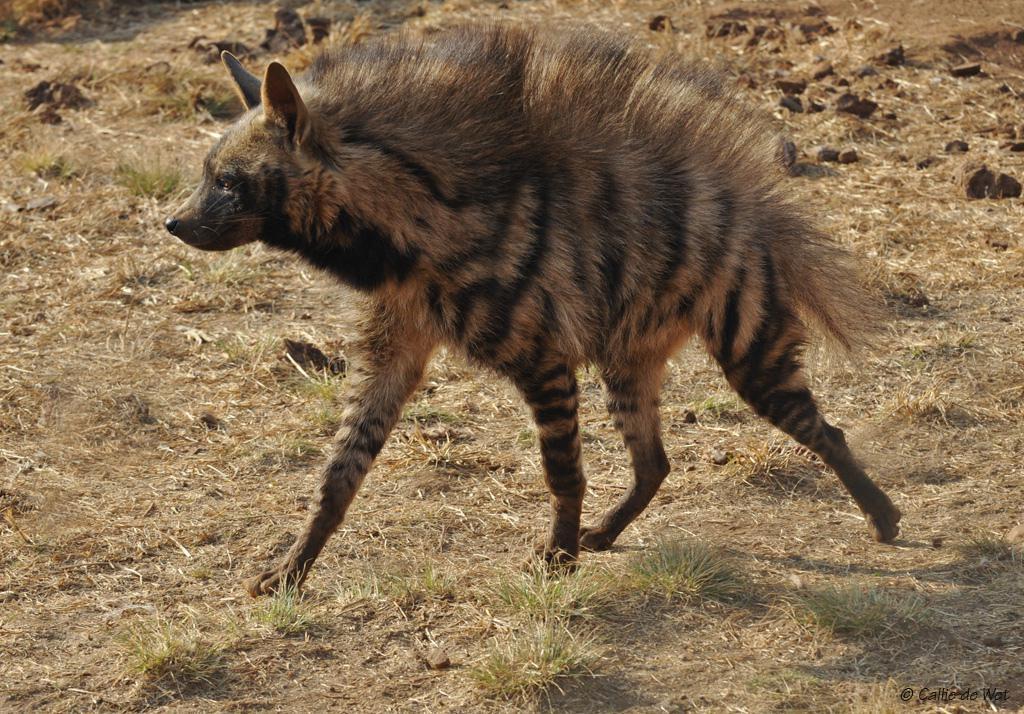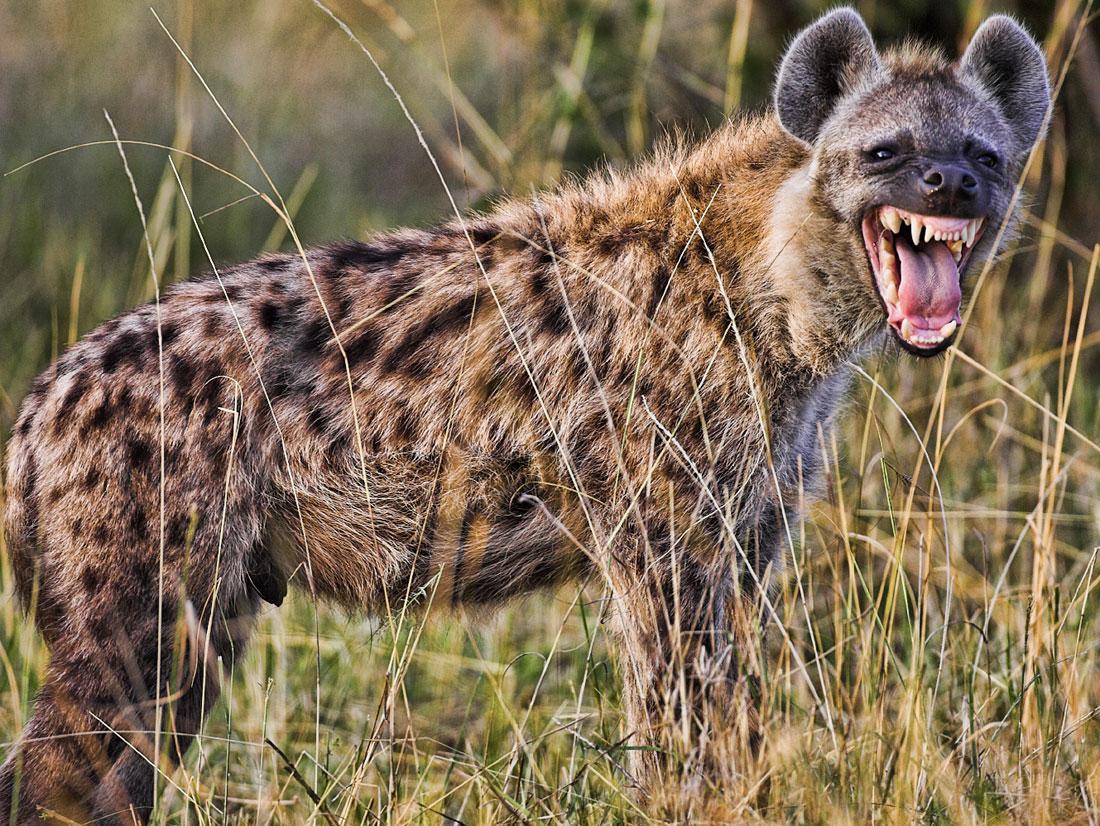The first image is the image on the left, the second image is the image on the right. For the images shown, is this caption "An image shows only an upright hyena with erect hair running the length of its body." true? Answer yes or no. Yes. The first image is the image on the left, the second image is the image on the right. Considering the images on both sides, is "One of the animals on the right is baring its teeth." valid? Answer yes or no. Yes. 